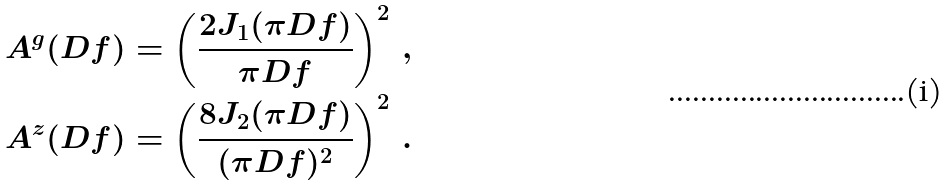Convert formula to latex. <formula><loc_0><loc_0><loc_500><loc_500>A ^ { g } ( D f ) = \left ( \frac { 2 J _ { 1 } ( \pi D f ) } { \pi D f } \right ) ^ { 2 } \, , \\ A ^ { z } ( D f ) = \left ( \frac { 8 J _ { 2 } ( \pi D f ) } { ( \pi D f ) ^ { 2 } } \right ) ^ { 2 } \, .</formula> 